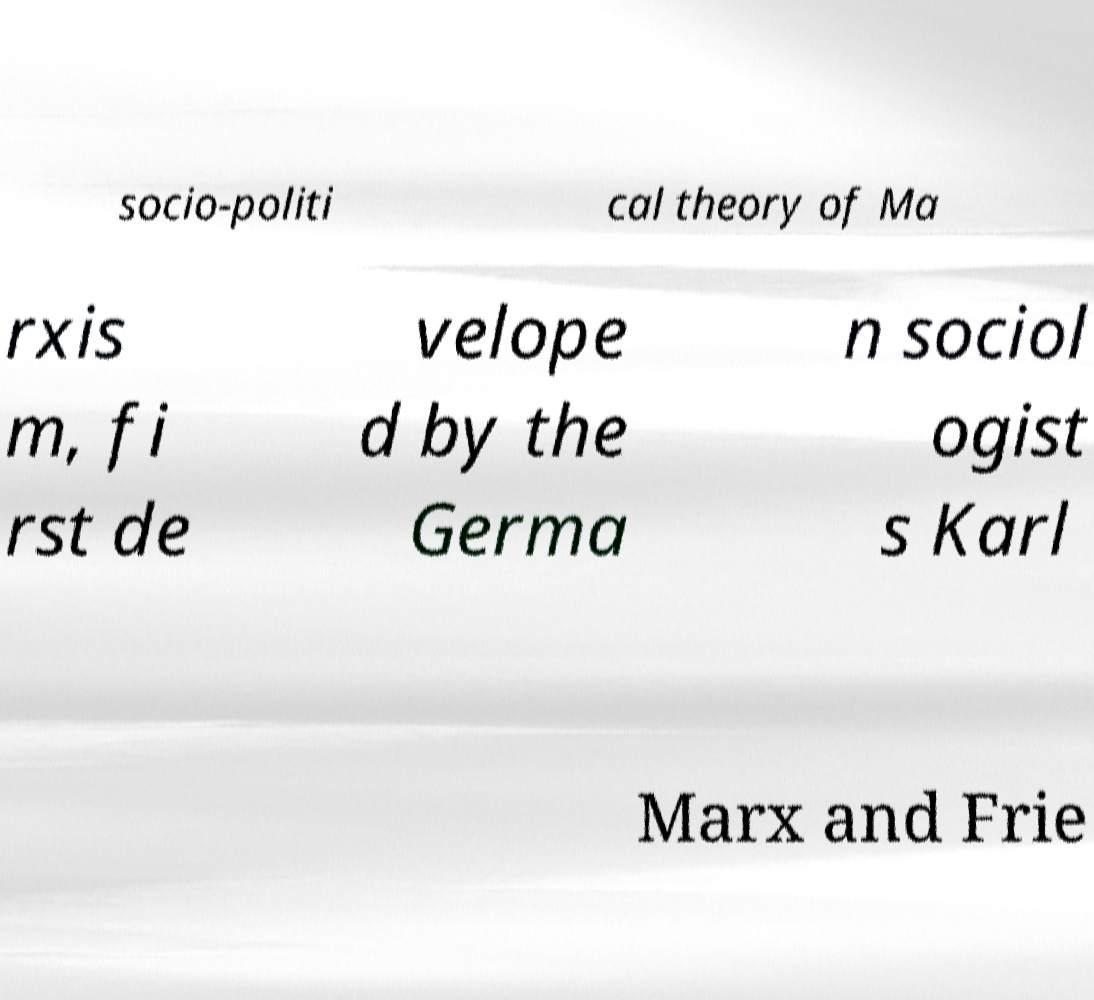I need the written content from this picture converted into text. Can you do that? socio-politi cal theory of Ma rxis m, fi rst de velope d by the Germa n sociol ogist s Karl Marx and Frie 